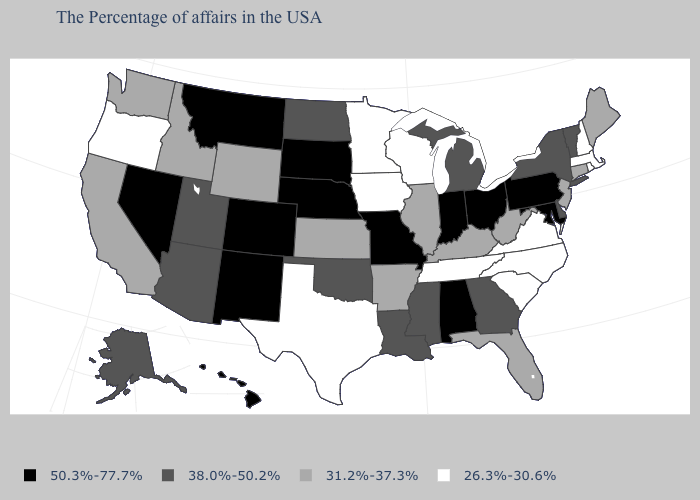What is the value of New Jersey?
Short answer required. 31.2%-37.3%. Name the states that have a value in the range 38.0%-50.2%?
Answer briefly. Vermont, New York, Delaware, Georgia, Michigan, Mississippi, Louisiana, Oklahoma, North Dakota, Utah, Arizona, Alaska. Is the legend a continuous bar?
Answer briefly. No. What is the value of Louisiana?
Answer briefly. 38.0%-50.2%. What is the value of Colorado?
Be succinct. 50.3%-77.7%. What is the highest value in the South ?
Keep it brief. 50.3%-77.7%. What is the value of Oklahoma?
Be succinct. 38.0%-50.2%. What is the value of Illinois?
Answer briefly. 31.2%-37.3%. Does Tennessee have the lowest value in the USA?
Quick response, please. Yes. Among the states that border Massachusetts , does Rhode Island have the lowest value?
Keep it brief. Yes. Does New Mexico have the highest value in the USA?
Concise answer only. Yes. Name the states that have a value in the range 31.2%-37.3%?
Give a very brief answer. Maine, Connecticut, New Jersey, West Virginia, Florida, Kentucky, Illinois, Arkansas, Kansas, Wyoming, Idaho, California, Washington. Does Ohio have the same value as Wyoming?
Short answer required. No. What is the value of New York?
Keep it brief. 38.0%-50.2%. What is the value of Arizona?
Concise answer only. 38.0%-50.2%. 